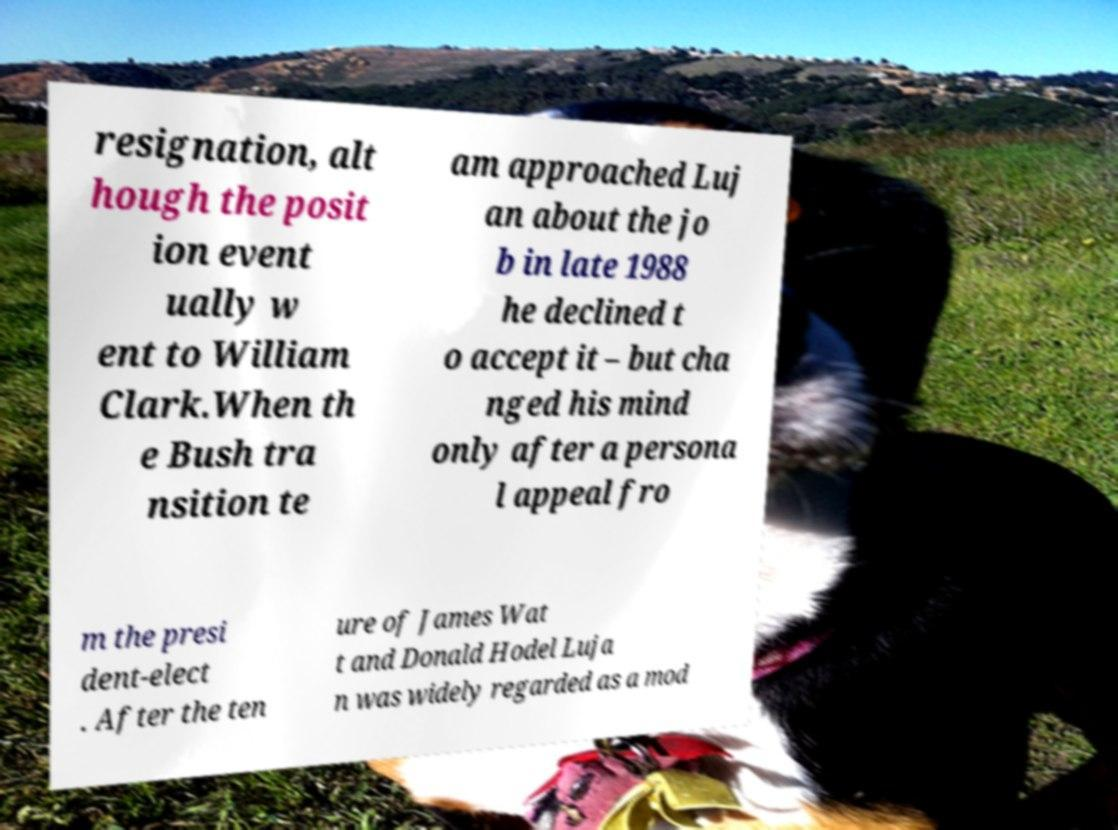There's text embedded in this image that I need extracted. Can you transcribe it verbatim? resignation, alt hough the posit ion event ually w ent to William Clark.When th e Bush tra nsition te am approached Luj an about the jo b in late 1988 he declined t o accept it – but cha nged his mind only after a persona l appeal fro m the presi dent-elect . After the ten ure of James Wat t and Donald Hodel Luja n was widely regarded as a mod 